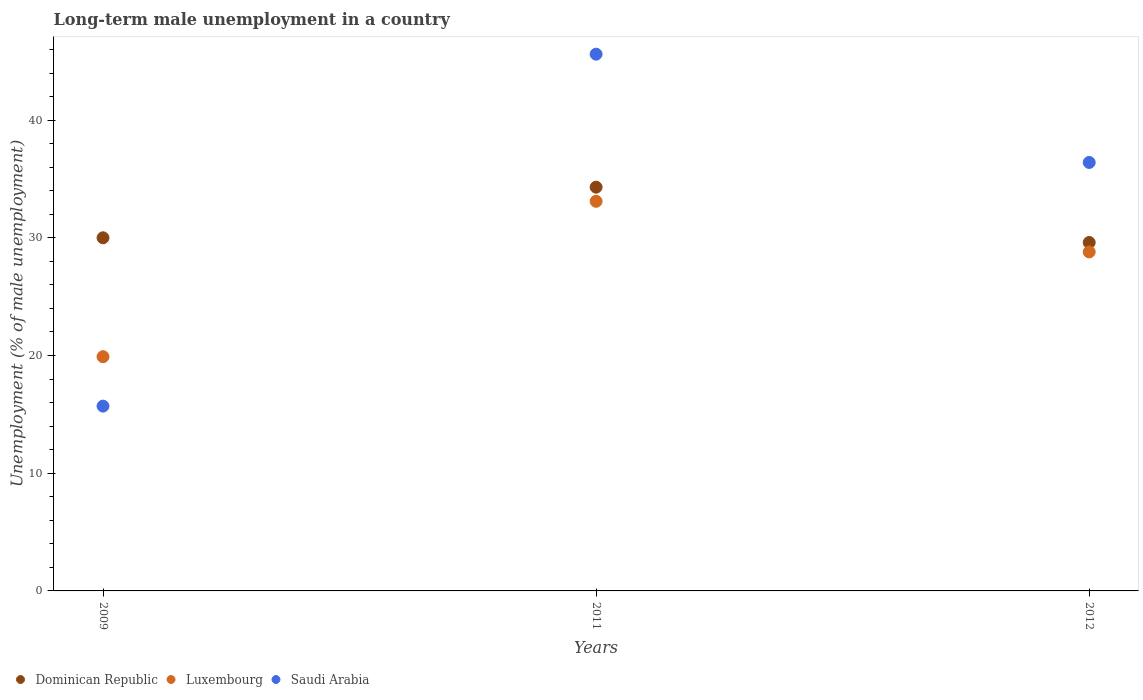What is the percentage of long-term unemployed male population in Saudi Arabia in 2011?
Keep it short and to the point. 45.6. Across all years, what is the maximum percentage of long-term unemployed male population in Luxembourg?
Your answer should be very brief. 33.1. Across all years, what is the minimum percentage of long-term unemployed male population in Luxembourg?
Ensure brevity in your answer.  19.9. In which year was the percentage of long-term unemployed male population in Saudi Arabia minimum?
Your response must be concise. 2009. What is the total percentage of long-term unemployed male population in Luxembourg in the graph?
Give a very brief answer. 81.8. What is the difference between the percentage of long-term unemployed male population in Saudi Arabia in 2009 and that in 2012?
Keep it short and to the point. -20.7. What is the difference between the percentage of long-term unemployed male population in Dominican Republic in 2011 and the percentage of long-term unemployed male population in Luxembourg in 2009?
Make the answer very short. 14.4. What is the average percentage of long-term unemployed male population in Luxembourg per year?
Give a very brief answer. 27.27. In the year 2012, what is the difference between the percentage of long-term unemployed male population in Luxembourg and percentage of long-term unemployed male population in Dominican Republic?
Make the answer very short. -0.8. What is the ratio of the percentage of long-term unemployed male population in Luxembourg in 2009 to that in 2012?
Offer a terse response. 0.69. Is the percentage of long-term unemployed male population in Luxembourg in 2009 less than that in 2012?
Your answer should be compact. Yes. Is the difference between the percentage of long-term unemployed male population in Luxembourg in 2009 and 2012 greater than the difference between the percentage of long-term unemployed male population in Dominican Republic in 2009 and 2012?
Make the answer very short. No. What is the difference between the highest and the second highest percentage of long-term unemployed male population in Luxembourg?
Offer a terse response. 4.3. What is the difference between the highest and the lowest percentage of long-term unemployed male population in Dominican Republic?
Give a very brief answer. 4.7. Does the percentage of long-term unemployed male population in Saudi Arabia monotonically increase over the years?
Your answer should be compact. No. Is the percentage of long-term unemployed male population in Luxembourg strictly less than the percentage of long-term unemployed male population in Dominican Republic over the years?
Provide a short and direct response. Yes. What is the difference between two consecutive major ticks on the Y-axis?
Ensure brevity in your answer.  10. Does the graph contain any zero values?
Your response must be concise. No. Does the graph contain grids?
Provide a succinct answer. No. How many legend labels are there?
Ensure brevity in your answer.  3. How are the legend labels stacked?
Give a very brief answer. Horizontal. What is the title of the graph?
Offer a very short reply. Long-term male unemployment in a country. Does "Rwanda" appear as one of the legend labels in the graph?
Make the answer very short. No. What is the label or title of the Y-axis?
Your response must be concise. Unemployment (% of male unemployment). What is the Unemployment (% of male unemployment) in Luxembourg in 2009?
Provide a short and direct response. 19.9. What is the Unemployment (% of male unemployment) in Saudi Arabia in 2009?
Provide a short and direct response. 15.7. What is the Unemployment (% of male unemployment) of Dominican Republic in 2011?
Make the answer very short. 34.3. What is the Unemployment (% of male unemployment) of Luxembourg in 2011?
Offer a very short reply. 33.1. What is the Unemployment (% of male unemployment) in Saudi Arabia in 2011?
Provide a short and direct response. 45.6. What is the Unemployment (% of male unemployment) in Dominican Republic in 2012?
Make the answer very short. 29.6. What is the Unemployment (% of male unemployment) of Luxembourg in 2012?
Provide a short and direct response. 28.8. What is the Unemployment (% of male unemployment) in Saudi Arabia in 2012?
Your answer should be very brief. 36.4. Across all years, what is the maximum Unemployment (% of male unemployment) of Dominican Republic?
Make the answer very short. 34.3. Across all years, what is the maximum Unemployment (% of male unemployment) of Luxembourg?
Ensure brevity in your answer.  33.1. Across all years, what is the maximum Unemployment (% of male unemployment) in Saudi Arabia?
Your answer should be very brief. 45.6. Across all years, what is the minimum Unemployment (% of male unemployment) of Dominican Republic?
Offer a very short reply. 29.6. Across all years, what is the minimum Unemployment (% of male unemployment) of Luxembourg?
Your answer should be compact. 19.9. Across all years, what is the minimum Unemployment (% of male unemployment) in Saudi Arabia?
Make the answer very short. 15.7. What is the total Unemployment (% of male unemployment) in Dominican Republic in the graph?
Offer a terse response. 93.9. What is the total Unemployment (% of male unemployment) of Luxembourg in the graph?
Your response must be concise. 81.8. What is the total Unemployment (% of male unemployment) of Saudi Arabia in the graph?
Keep it short and to the point. 97.7. What is the difference between the Unemployment (% of male unemployment) of Saudi Arabia in 2009 and that in 2011?
Offer a terse response. -29.9. What is the difference between the Unemployment (% of male unemployment) of Luxembourg in 2009 and that in 2012?
Give a very brief answer. -8.9. What is the difference between the Unemployment (% of male unemployment) in Saudi Arabia in 2009 and that in 2012?
Provide a short and direct response. -20.7. What is the difference between the Unemployment (% of male unemployment) in Dominican Republic in 2011 and that in 2012?
Keep it short and to the point. 4.7. What is the difference between the Unemployment (% of male unemployment) of Dominican Republic in 2009 and the Unemployment (% of male unemployment) of Luxembourg in 2011?
Provide a succinct answer. -3.1. What is the difference between the Unemployment (% of male unemployment) of Dominican Republic in 2009 and the Unemployment (% of male unemployment) of Saudi Arabia in 2011?
Make the answer very short. -15.6. What is the difference between the Unemployment (% of male unemployment) of Luxembourg in 2009 and the Unemployment (% of male unemployment) of Saudi Arabia in 2011?
Provide a succinct answer. -25.7. What is the difference between the Unemployment (% of male unemployment) in Dominican Republic in 2009 and the Unemployment (% of male unemployment) in Luxembourg in 2012?
Your answer should be compact. 1.2. What is the difference between the Unemployment (% of male unemployment) in Luxembourg in 2009 and the Unemployment (% of male unemployment) in Saudi Arabia in 2012?
Offer a very short reply. -16.5. What is the difference between the Unemployment (% of male unemployment) in Dominican Republic in 2011 and the Unemployment (% of male unemployment) in Luxembourg in 2012?
Keep it short and to the point. 5.5. What is the difference between the Unemployment (% of male unemployment) of Dominican Republic in 2011 and the Unemployment (% of male unemployment) of Saudi Arabia in 2012?
Provide a succinct answer. -2.1. What is the difference between the Unemployment (% of male unemployment) of Luxembourg in 2011 and the Unemployment (% of male unemployment) of Saudi Arabia in 2012?
Provide a short and direct response. -3.3. What is the average Unemployment (% of male unemployment) of Dominican Republic per year?
Your answer should be very brief. 31.3. What is the average Unemployment (% of male unemployment) in Luxembourg per year?
Your response must be concise. 27.27. What is the average Unemployment (% of male unemployment) of Saudi Arabia per year?
Ensure brevity in your answer.  32.57. In the year 2009, what is the difference between the Unemployment (% of male unemployment) in Dominican Republic and Unemployment (% of male unemployment) in Luxembourg?
Ensure brevity in your answer.  10.1. In the year 2009, what is the difference between the Unemployment (% of male unemployment) of Dominican Republic and Unemployment (% of male unemployment) of Saudi Arabia?
Your answer should be compact. 14.3. In the year 2009, what is the difference between the Unemployment (% of male unemployment) in Luxembourg and Unemployment (% of male unemployment) in Saudi Arabia?
Offer a terse response. 4.2. In the year 2011, what is the difference between the Unemployment (% of male unemployment) of Dominican Republic and Unemployment (% of male unemployment) of Saudi Arabia?
Your response must be concise. -11.3. In the year 2011, what is the difference between the Unemployment (% of male unemployment) of Luxembourg and Unemployment (% of male unemployment) of Saudi Arabia?
Your answer should be compact. -12.5. In the year 2012, what is the difference between the Unemployment (% of male unemployment) of Dominican Republic and Unemployment (% of male unemployment) of Luxembourg?
Provide a succinct answer. 0.8. In the year 2012, what is the difference between the Unemployment (% of male unemployment) of Luxembourg and Unemployment (% of male unemployment) of Saudi Arabia?
Give a very brief answer. -7.6. What is the ratio of the Unemployment (% of male unemployment) in Dominican Republic in 2009 to that in 2011?
Offer a terse response. 0.87. What is the ratio of the Unemployment (% of male unemployment) of Luxembourg in 2009 to that in 2011?
Ensure brevity in your answer.  0.6. What is the ratio of the Unemployment (% of male unemployment) in Saudi Arabia in 2009 to that in 2011?
Your response must be concise. 0.34. What is the ratio of the Unemployment (% of male unemployment) of Dominican Republic in 2009 to that in 2012?
Provide a short and direct response. 1.01. What is the ratio of the Unemployment (% of male unemployment) in Luxembourg in 2009 to that in 2012?
Offer a terse response. 0.69. What is the ratio of the Unemployment (% of male unemployment) in Saudi Arabia in 2009 to that in 2012?
Give a very brief answer. 0.43. What is the ratio of the Unemployment (% of male unemployment) of Dominican Republic in 2011 to that in 2012?
Your response must be concise. 1.16. What is the ratio of the Unemployment (% of male unemployment) in Luxembourg in 2011 to that in 2012?
Provide a succinct answer. 1.15. What is the ratio of the Unemployment (% of male unemployment) of Saudi Arabia in 2011 to that in 2012?
Your answer should be compact. 1.25. What is the difference between the highest and the second highest Unemployment (% of male unemployment) in Saudi Arabia?
Give a very brief answer. 9.2. What is the difference between the highest and the lowest Unemployment (% of male unemployment) in Dominican Republic?
Provide a short and direct response. 4.7. What is the difference between the highest and the lowest Unemployment (% of male unemployment) in Luxembourg?
Offer a terse response. 13.2. What is the difference between the highest and the lowest Unemployment (% of male unemployment) in Saudi Arabia?
Your answer should be very brief. 29.9. 